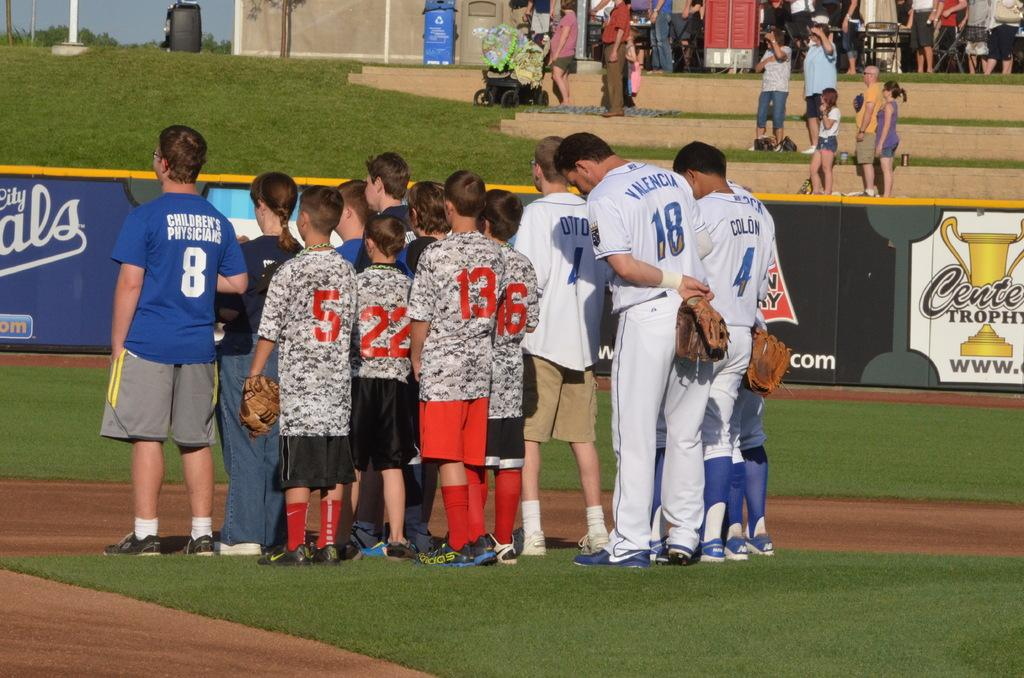<image>
Write a terse but informative summary of the picture. a person with a jersey that ahs the name Valencia on it 